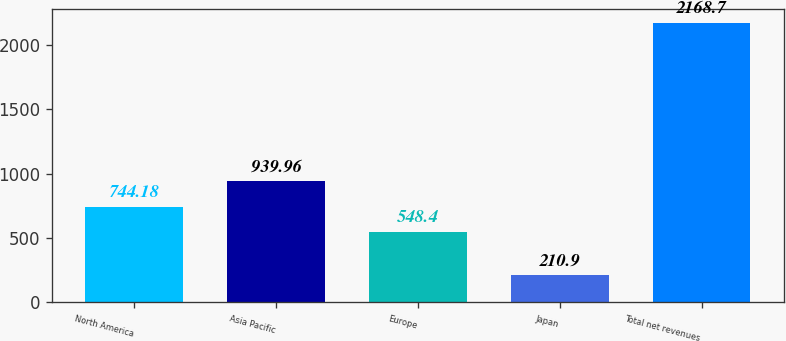Convert chart. <chart><loc_0><loc_0><loc_500><loc_500><bar_chart><fcel>North America<fcel>Asia Pacific<fcel>Europe<fcel>Japan<fcel>Total net revenues<nl><fcel>744.18<fcel>939.96<fcel>548.4<fcel>210.9<fcel>2168.7<nl></chart> 